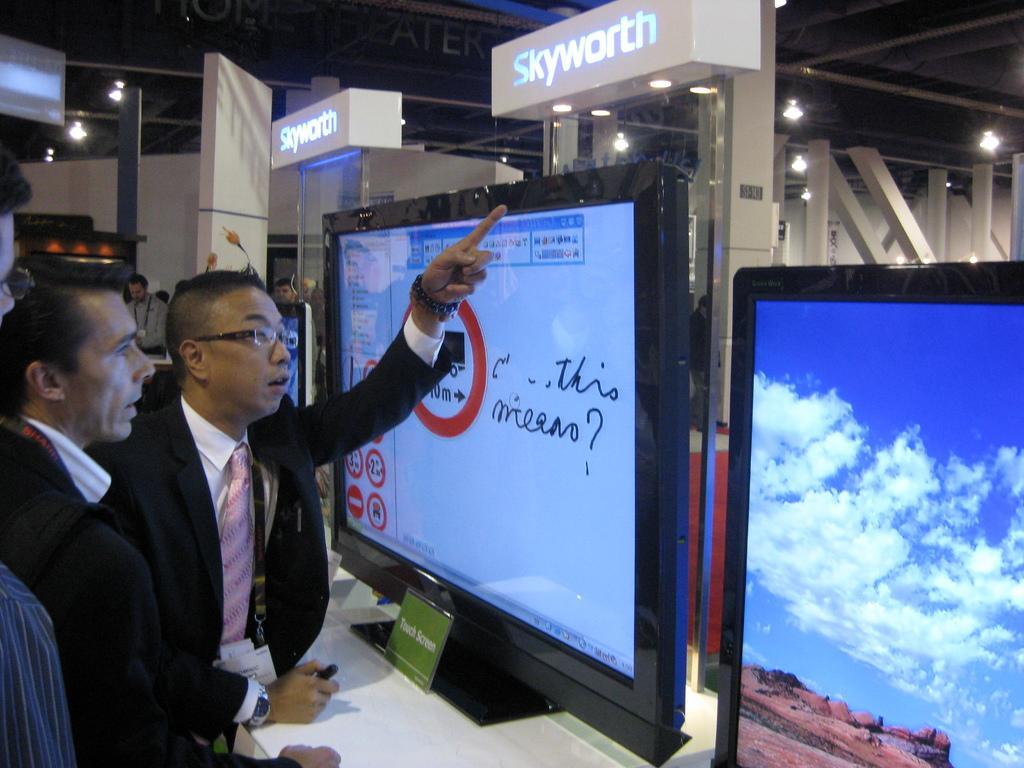Describe this image in one or two sentences. Left side of the image we can see people. Front this person wore a suit and tie. On this white table there are monitors. These are lights.  